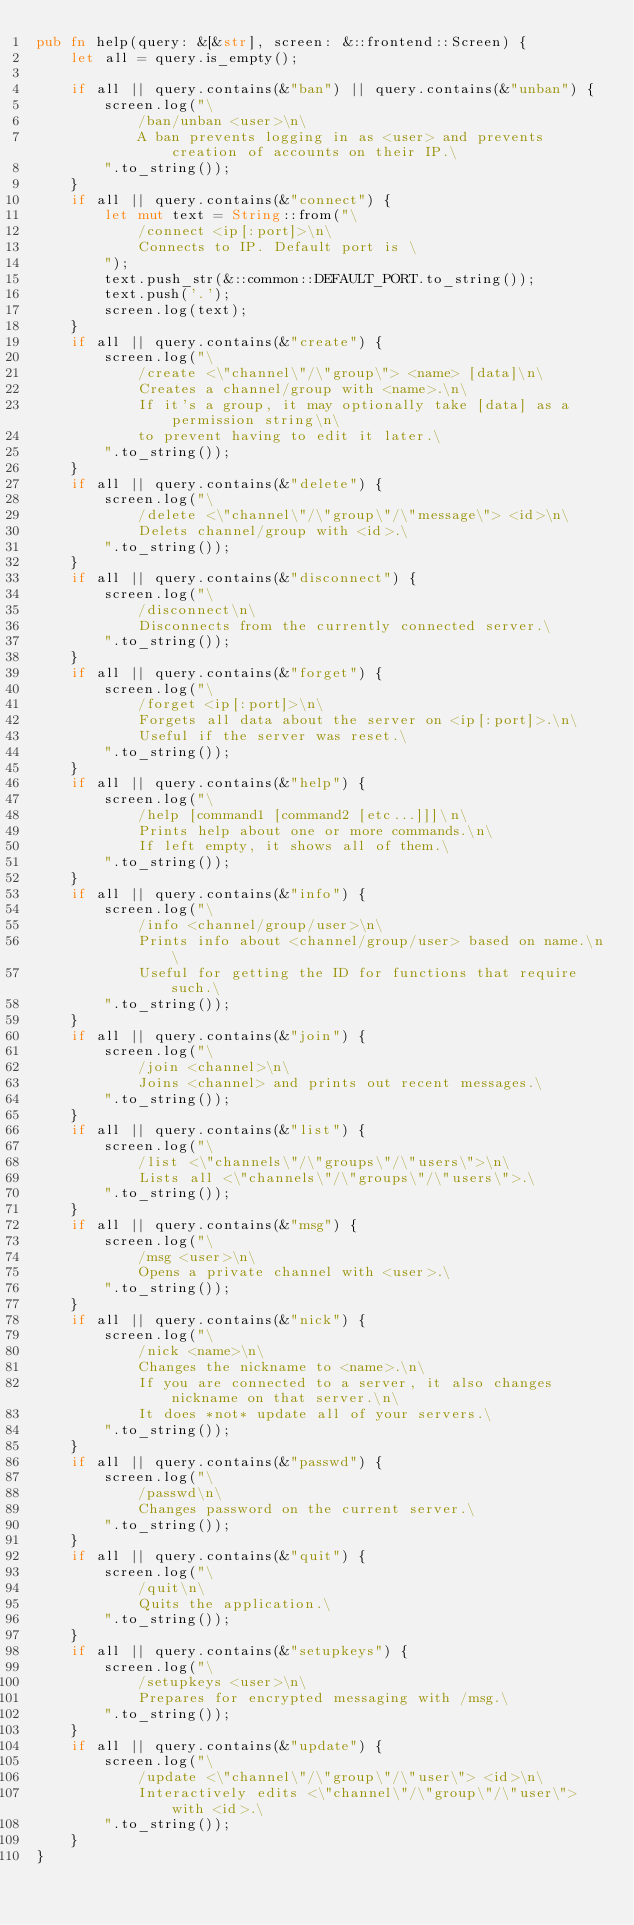<code> <loc_0><loc_0><loc_500><loc_500><_Rust_>pub fn help(query: &[&str], screen: &::frontend::Screen) {
    let all = query.is_empty();

    if all || query.contains(&"ban") || query.contains(&"unban") {
        screen.log("\
            /ban/unban <user>\n\
            A ban prevents logging in as <user> and prevents creation of accounts on their IP.\
        ".to_string());
    }
    if all || query.contains(&"connect") {
        let mut text = String::from("\
            /connect <ip[:port]>\n\
            Connects to IP. Default port is \
        ");
        text.push_str(&::common::DEFAULT_PORT.to_string());
        text.push('.');
        screen.log(text);
    }
    if all || query.contains(&"create") {
        screen.log("\
            /create <\"channel\"/\"group\"> <name> [data]\n\
            Creates a channel/group with <name>.\n\
            If it's a group, it may optionally take [data] as a permission string\n\
            to prevent having to edit it later.\
        ".to_string());
    }
    if all || query.contains(&"delete") {
        screen.log("\
            /delete <\"channel\"/\"group\"/\"message\"> <id>\n\
            Delets channel/group with <id>.\
        ".to_string());
    }
    if all || query.contains(&"disconnect") {
        screen.log("\
            /disconnect\n\
            Disconnects from the currently connected server.\
        ".to_string());
    }
    if all || query.contains(&"forget") {
        screen.log("\
            /forget <ip[:port]>\n\
            Forgets all data about the server on <ip[:port]>.\n\
            Useful if the server was reset.\
        ".to_string());
    }
    if all || query.contains(&"help") {
        screen.log("\
            /help [command1 [command2 [etc...]]]\n\
            Prints help about one or more commands.\n\
            If left empty, it shows all of them.\
        ".to_string());
    }
    if all || query.contains(&"info") {
        screen.log("\
            /info <channel/group/user>\n\
            Prints info about <channel/group/user> based on name.\n\
            Useful for getting the ID for functions that require such.\
        ".to_string());
    }
    if all || query.contains(&"join") {
        screen.log("\
            /join <channel>\n\
            Joins <channel> and prints out recent messages.\
        ".to_string());
    }
    if all || query.contains(&"list") {
        screen.log("\
            /list <\"channels\"/\"groups\"/\"users\">\n\
            Lists all <\"channels\"/\"groups\"/\"users\">.\
        ".to_string());
    }
    if all || query.contains(&"msg") {
        screen.log("\
            /msg <user>\n\
            Opens a private channel with <user>.\
        ".to_string());
    }
    if all || query.contains(&"nick") {
        screen.log("\
            /nick <name>\n\
            Changes the nickname to <name>.\n\
            If you are connected to a server, it also changes nickname on that server.\n\
            It does *not* update all of your servers.\
        ".to_string());
    }
    if all || query.contains(&"passwd") {
        screen.log("\
            /passwd\n\
            Changes password on the current server.\
        ".to_string());
    }
    if all || query.contains(&"quit") {
        screen.log("\
            /quit\n\
            Quits the application.\
        ".to_string());
    }
    if all || query.contains(&"setupkeys") {
        screen.log("\
            /setupkeys <user>\n\
            Prepares for encrypted messaging with /msg.\
        ".to_string());
    }
    if all || query.contains(&"update") {
        screen.log("\
            /update <\"channel\"/\"group\"/\"user\"> <id>\n\
            Interactively edits <\"channel\"/\"group\"/\"user\"> with <id>.\
        ".to_string());
    }
}
</code> 